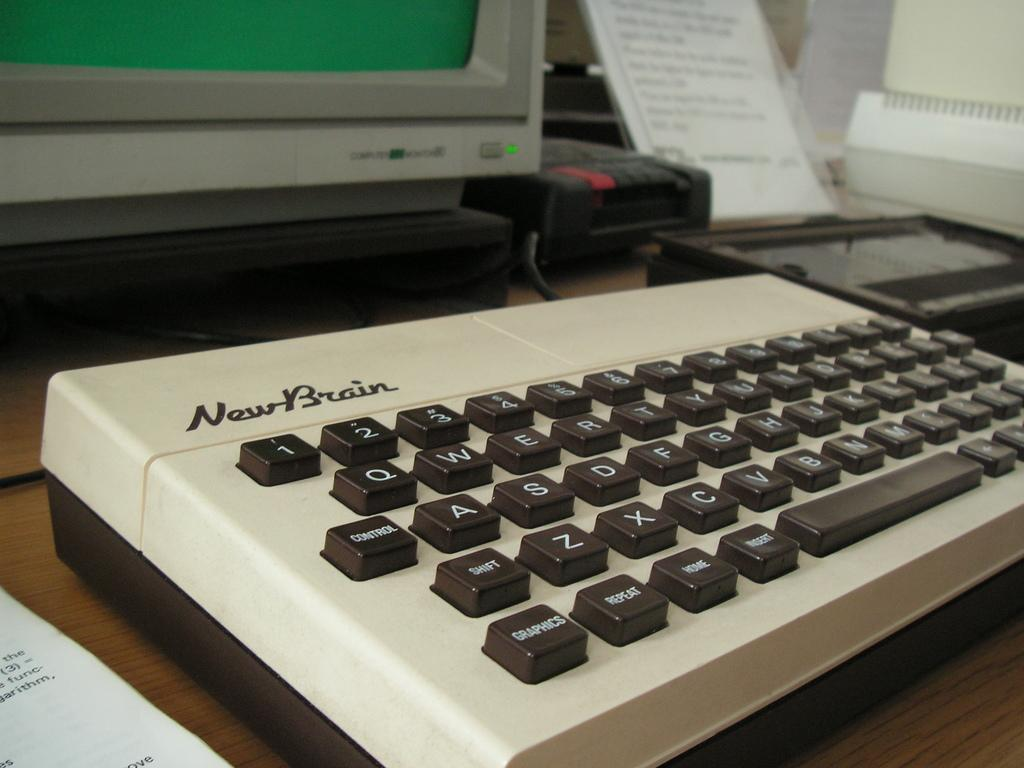What is on the table in the image? There is a keyboard, a paper, and a monitor on the table. What might the keyboard be used for? The keyboard might be used for typing or inputting information. What is the paper used for? The paper might be used for writing or printing information. What is the purpose of the monitor? The monitor might be used for displaying information or images. What type of soup is being served in the image? There is no soup present in the image; it features a keyboard, paper, and monitor on a table. 